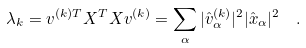<formula> <loc_0><loc_0><loc_500><loc_500>\lambda _ { k } = { v } ^ { ( k ) T } X ^ { T } X { v } ^ { ( k ) } = \sum _ { \alpha } | { \hat { v } } _ { \alpha } ^ { ( k ) } | ^ { 2 } | { \hat { x } } _ { \alpha } | ^ { 2 } \ \ .</formula> 